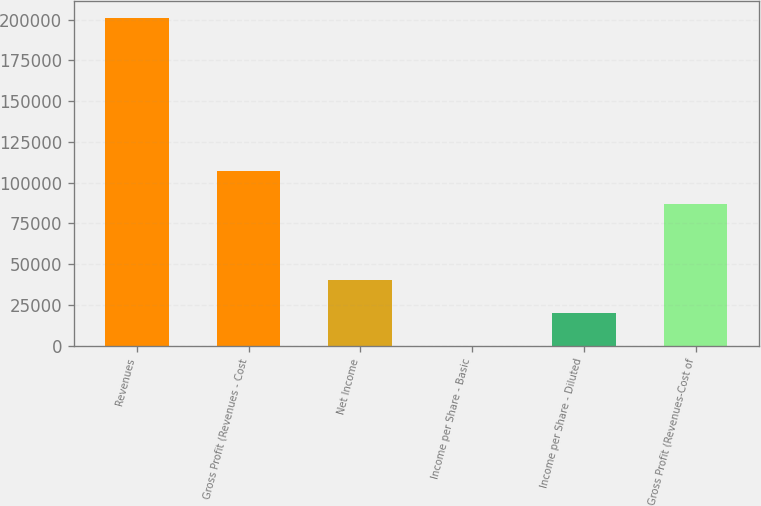<chart> <loc_0><loc_0><loc_500><loc_500><bar_chart><fcel>Revenues<fcel>Gross Profit (Revenues - Cost<fcel>Net Income<fcel>Income per Share - Basic<fcel>Income per Share - Diluted<fcel>Gross Profit (Revenues-Cost of<nl><fcel>201232<fcel>107296<fcel>40246.5<fcel>0.13<fcel>20123.3<fcel>87173<nl></chart> 